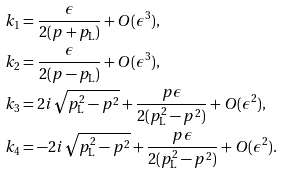<formula> <loc_0><loc_0><loc_500><loc_500>k _ { 1 } & = \frac { \epsilon } { 2 ( p + p _ { \text {L} } ) } + O ( \epsilon ^ { 3 } ) , \\ k _ { 2 } & = \frac { \epsilon } { 2 ( p - p _ { \text {L} } ) } + O ( \epsilon ^ { 3 } ) , \\ k _ { 3 } & = 2 i \sqrt { p _ { \text {L} } ^ { 2 } - p ^ { 2 } } + \frac { p \epsilon } { 2 ( p _ { \text {L} } ^ { 2 } - p ^ { 2 } ) } + O ( \epsilon ^ { 2 } ) , \\ k _ { 4 } & = - 2 i \sqrt { p _ { \text {L} } ^ { 2 } - p ^ { 2 } } + \frac { p \epsilon } { 2 ( p _ { \text {L} } ^ { 2 } - p ^ { 2 } ) } + O ( \epsilon ^ { 2 } ) .</formula> 